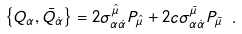Convert formula to latex. <formula><loc_0><loc_0><loc_500><loc_500>\left \{ Q _ { \alpha } , \bar { Q } _ { \dot { \alpha } } \right \} = 2 \sigma ^ { \hat { \mu } } _ { \alpha \dot { \alpha } } P _ { \hat { \mu } } + 2 c \sigma ^ { \bar { \mu } } _ { \alpha \dot { \alpha } } P _ { \bar { \mu } } \ .</formula> 